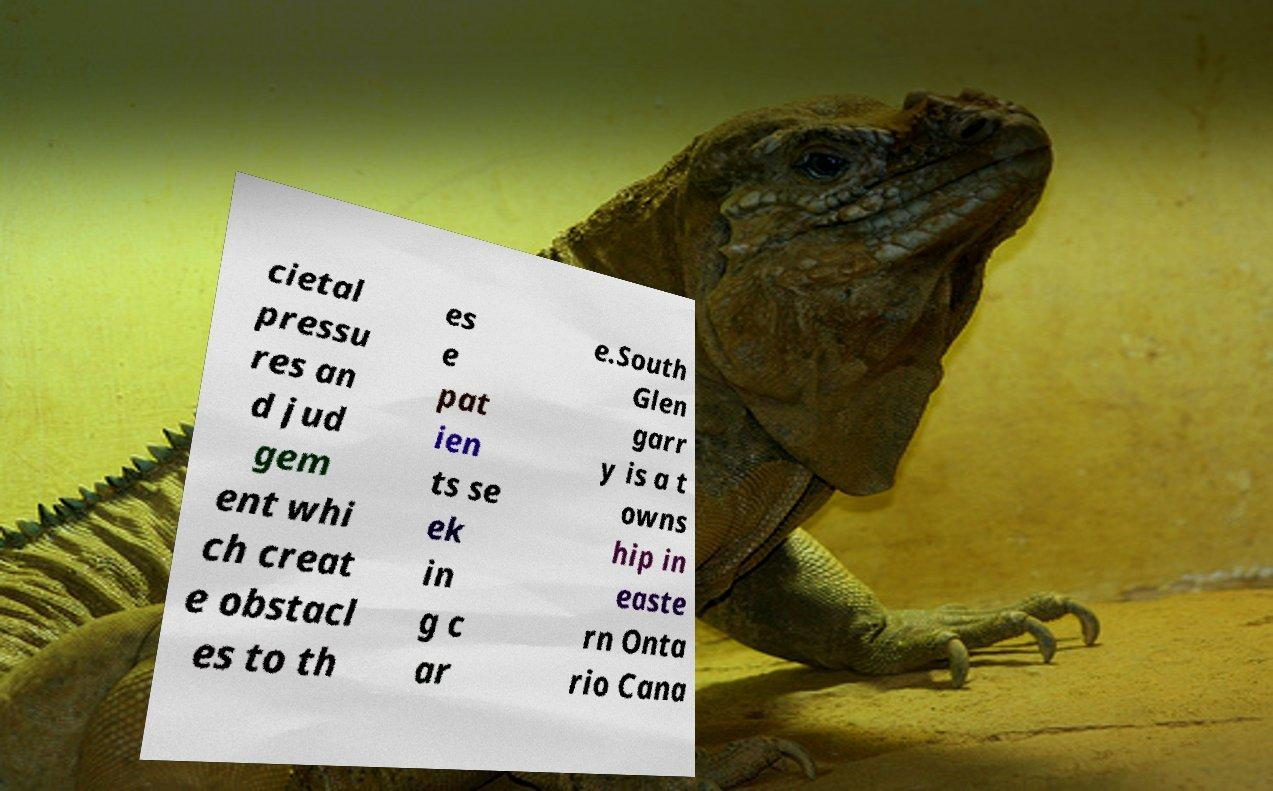Please identify and transcribe the text found in this image. cietal pressu res an d jud gem ent whi ch creat e obstacl es to th es e pat ien ts se ek in g c ar e.South Glen garr y is a t owns hip in easte rn Onta rio Cana 